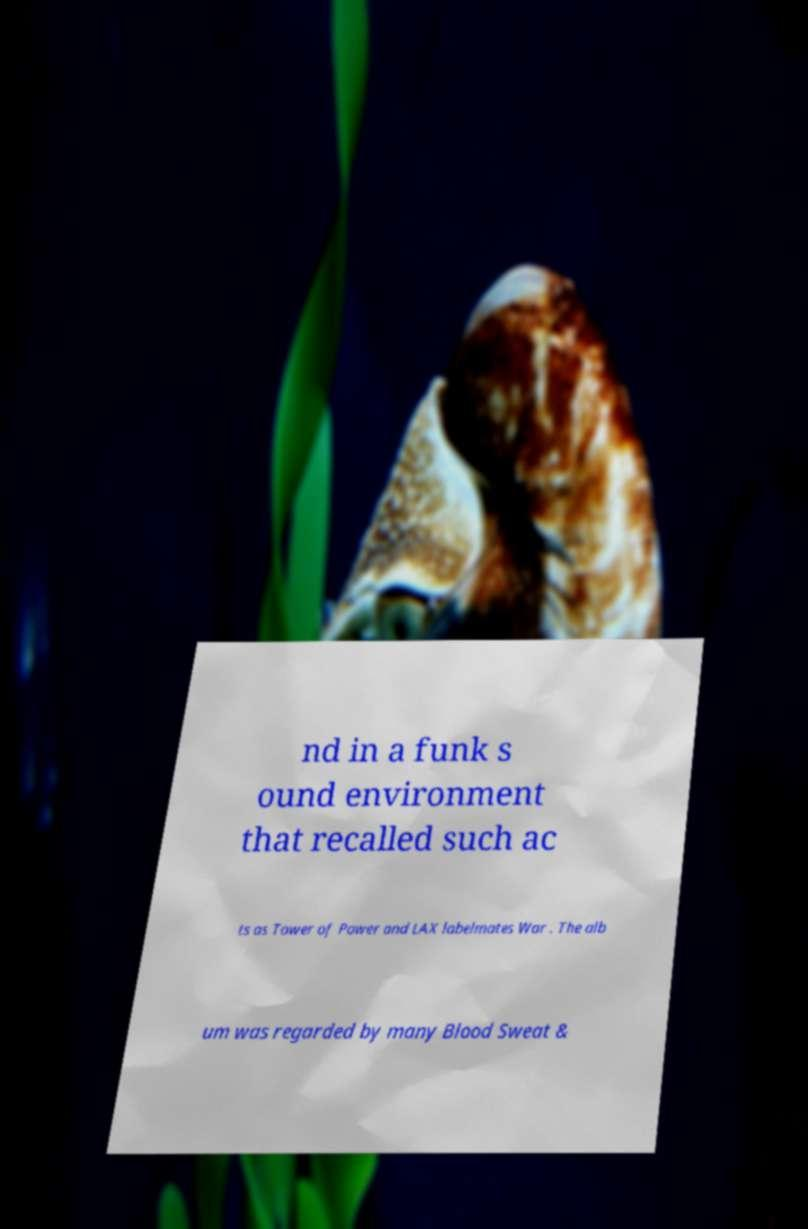There's text embedded in this image that I need extracted. Can you transcribe it verbatim? nd in a funk s ound environment that recalled such ac ts as Tower of Power and LAX labelmates War . The alb um was regarded by many Blood Sweat & 